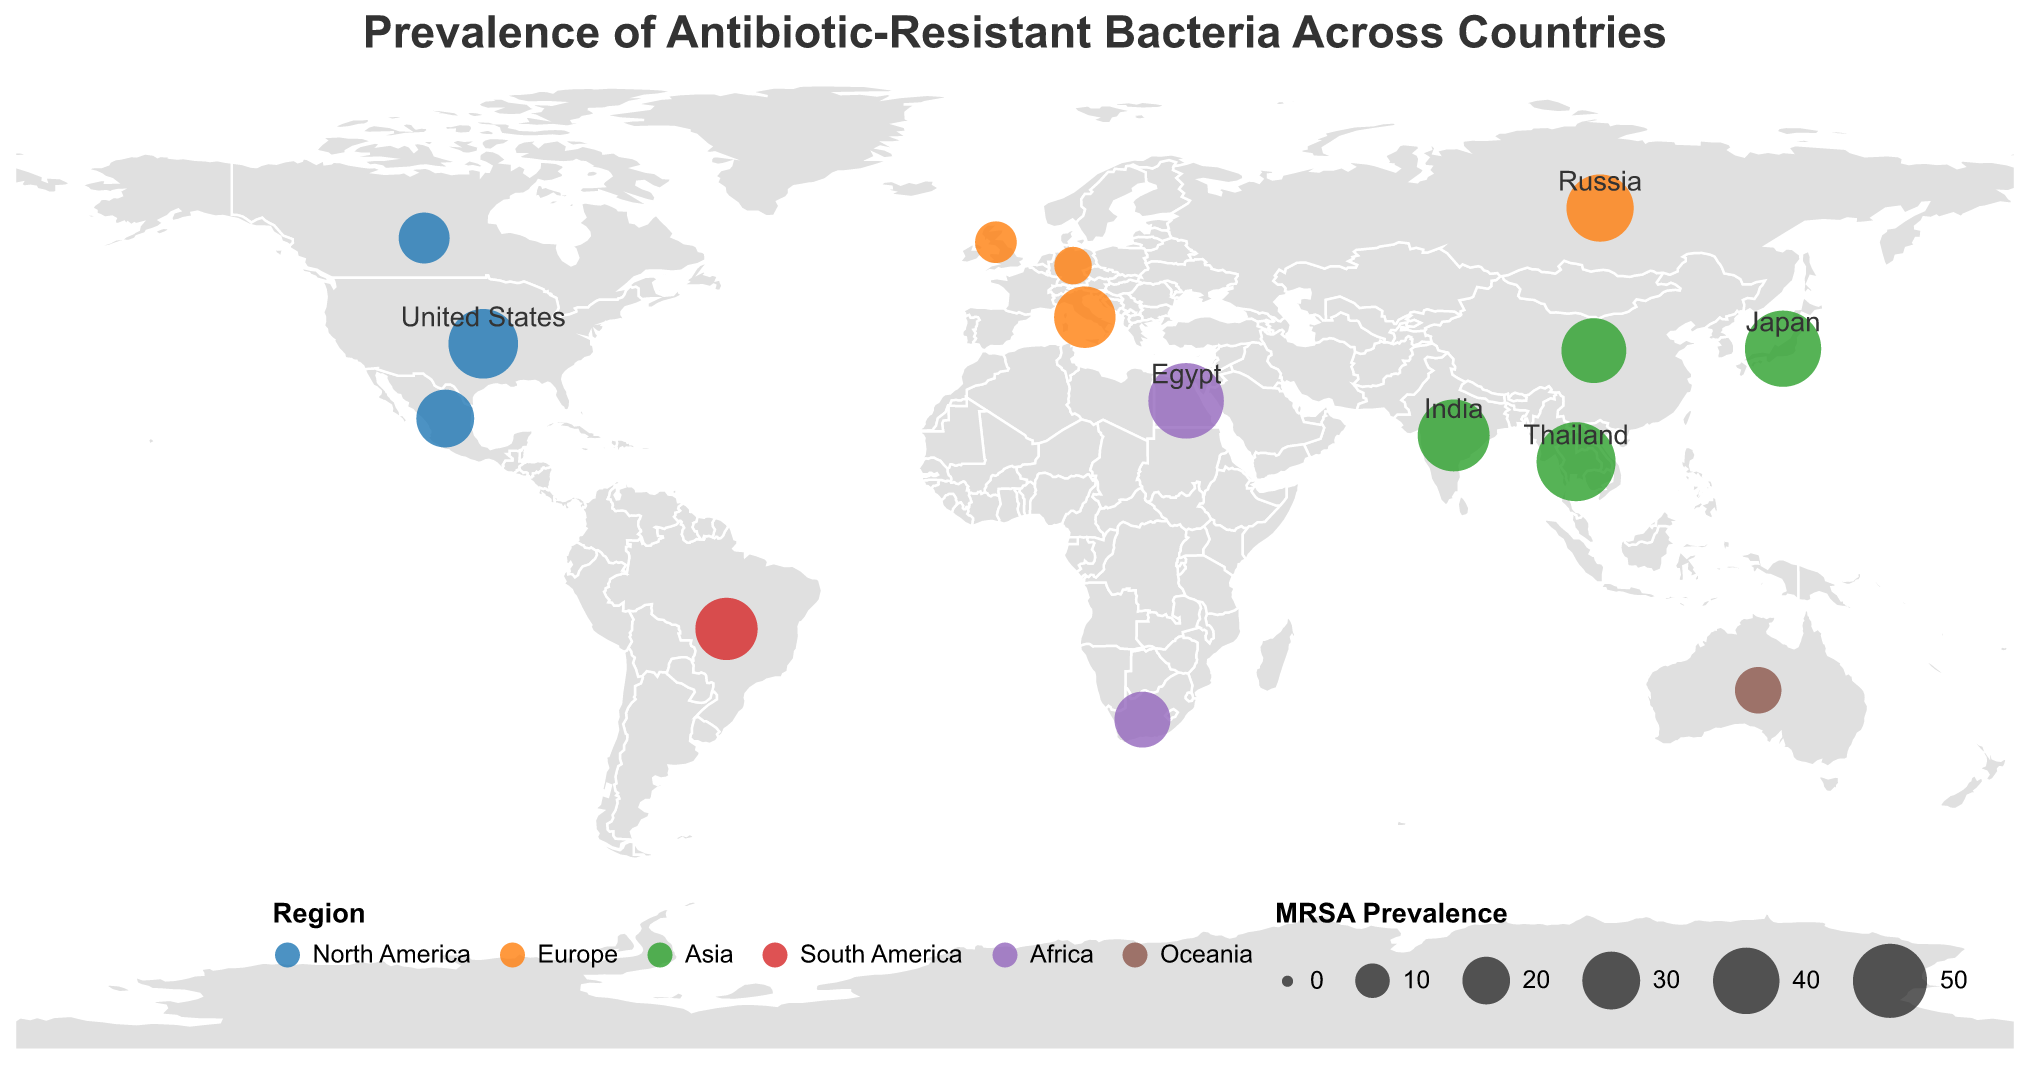What is the title of the figure? The title appears at the top of the chart and provides an overview of what the figure depicts. In this case, it mentions "Prevalence of Antibiotic-Resistant Bacteria Across Countries."
Answer: Prevalence of Antibiotic-Resistant Bacteria Across Countries Which region has the highest MRSA prevalence? To answer this, identify the region with the highest MRSA prevalence value among the data points. Thailand from Asia shows the highest MRSA prevalence (57).
Answer: Asia What is the median prevalence of VRE among the countries listed? To find the median, list all VRE prevalence values in ascending order and pick the middle value. Sorted values: 5, 7, 8, 10, 12, 15, 15, 18, 18, 20, 22, 25, 28, 30, 35. The median is the 8th value.
Answer: 18 Compare the prevalence of CRE between the United States and Egypt. Which country has a higher prevalence? Look at the data for the CRE prevalence values for the United States (5) and Egypt (9). Egypt has a higher prevalence.
Answer: Egypt How many countries in the figure are in the European region? Count the number of unique countries that are labeled as part of the European region: United Kingdom, Germany, Italy, Russia. There are 4 countries in Europe.
Answer: 4 Which two countries have the lowest prevalence of CRE? Order the CRE prevalence values and pick the two smallest values. The smallest values are Japan (0.5) and Canada (0.3).
Answer: Japan and Canada Identify the countries in North America and their respective MRSA prevalence. Look at the data and list the countries in North America along with their MRSA prevalence values: United States (44), Canada (23), Mexico (30).
Answer: United States: 44, Canada: 23, Mexico: 30 Which country has the highest prevalence of all three types of antibiotic-resistant bacteria combined (MRSA, VRE, and CRE)? Sum the prevalence values for MRSA, VRE, and CRE for each country and find the maximum. Thailand has the combined highest prevalence (MRSA: 57, VRE: 28, CRE: 7), total being 92.
Answer: Thailand What is the average prevalence of MRSA among the countries in Asia? Add the MRSA prevalence values for countries in Asia and divide by the number of countries in Asia (Japan: 53, India: 47, China: 38, Thailand: 57). The sum is 53 + 47 + 38 + 57 = 195. There are 4 countries, so 195/4 = 48.75.
Answer: 48.75 In which region, besides Asia, did any country exceed 50 in MRSA prevalence? Check the MRSA prevalence values of all regions except Asia and find any values exceeding 50. Egypt in Africa has a MRSA prevalence of 52.
Answer: Africa (Egypt) 